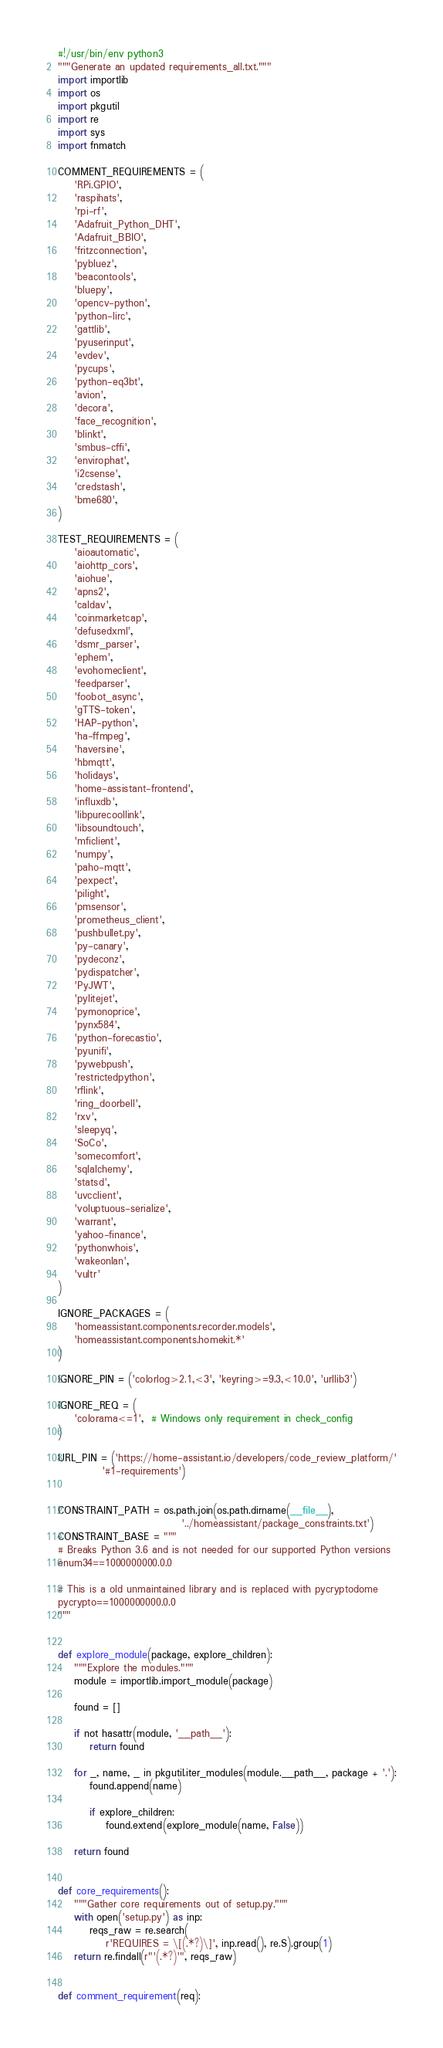Convert code to text. <code><loc_0><loc_0><loc_500><loc_500><_Python_>#!/usr/bin/env python3
"""Generate an updated requirements_all.txt."""
import importlib
import os
import pkgutil
import re
import sys
import fnmatch

COMMENT_REQUIREMENTS = (
    'RPi.GPIO',
    'raspihats',
    'rpi-rf',
    'Adafruit_Python_DHT',
    'Adafruit_BBIO',
    'fritzconnection',
    'pybluez',
    'beacontools',
    'bluepy',
    'opencv-python',
    'python-lirc',
    'gattlib',
    'pyuserinput',
    'evdev',
    'pycups',
    'python-eq3bt',
    'avion',
    'decora',
    'face_recognition',
    'blinkt',
    'smbus-cffi',
    'envirophat',
    'i2csense',
    'credstash',
    'bme680',
)

TEST_REQUIREMENTS = (
    'aioautomatic',
    'aiohttp_cors',
    'aiohue',
    'apns2',
    'caldav',
    'coinmarketcap',
    'defusedxml',
    'dsmr_parser',
    'ephem',
    'evohomeclient',
    'feedparser',
    'foobot_async',
    'gTTS-token',
    'HAP-python',
    'ha-ffmpeg',
    'haversine',
    'hbmqtt',
    'holidays',
    'home-assistant-frontend',
    'influxdb',
    'libpurecoollink',
    'libsoundtouch',
    'mficlient',
    'numpy',
    'paho-mqtt',
    'pexpect',
    'pilight',
    'pmsensor',
    'prometheus_client',
    'pushbullet.py',
    'py-canary',
    'pydeconz',
    'pydispatcher',
    'PyJWT',
    'pylitejet',
    'pymonoprice',
    'pynx584',
    'python-forecastio',
    'pyunifi',
    'pywebpush',
    'restrictedpython',
    'rflink',
    'ring_doorbell',
    'rxv',
    'sleepyq',
    'SoCo',
    'somecomfort',
    'sqlalchemy',
    'statsd',
    'uvcclient',
    'voluptuous-serialize',
    'warrant',
    'yahoo-finance',
    'pythonwhois',
    'wakeonlan',
    'vultr'
)

IGNORE_PACKAGES = (
    'homeassistant.components.recorder.models',
    'homeassistant.components.homekit.*'
)

IGNORE_PIN = ('colorlog>2.1,<3', 'keyring>=9.3,<10.0', 'urllib3')

IGNORE_REQ = (
    'colorama<=1',  # Windows only requirement in check_config
)

URL_PIN = ('https://home-assistant.io/developers/code_review_platform/'
           '#1-requirements')


CONSTRAINT_PATH = os.path.join(os.path.dirname(__file__),
                               '../homeassistant/package_constraints.txt')
CONSTRAINT_BASE = """
# Breaks Python 3.6 and is not needed for our supported Python versions
enum34==1000000000.0.0

# This is a old unmaintained library and is replaced with pycryptodome
pycrypto==1000000000.0.0
"""


def explore_module(package, explore_children):
    """Explore the modules."""
    module = importlib.import_module(package)

    found = []

    if not hasattr(module, '__path__'):
        return found

    for _, name, _ in pkgutil.iter_modules(module.__path__, package + '.'):
        found.append(name)

        if explore_children:
            found.extend(explore_module(name, False))

    return found


def core_requirements():
    """Gather core requirements out of setup.py."""
    with open('setup.py') as inp:
        reqs_raw = re.search(
            r'REQUIRES = \[(.*?)\]', inp.read(), re.S).group(1)
    return re.findall(r"'(.*?)'", reqs_raw)


def comment_requirement(req):</code> 